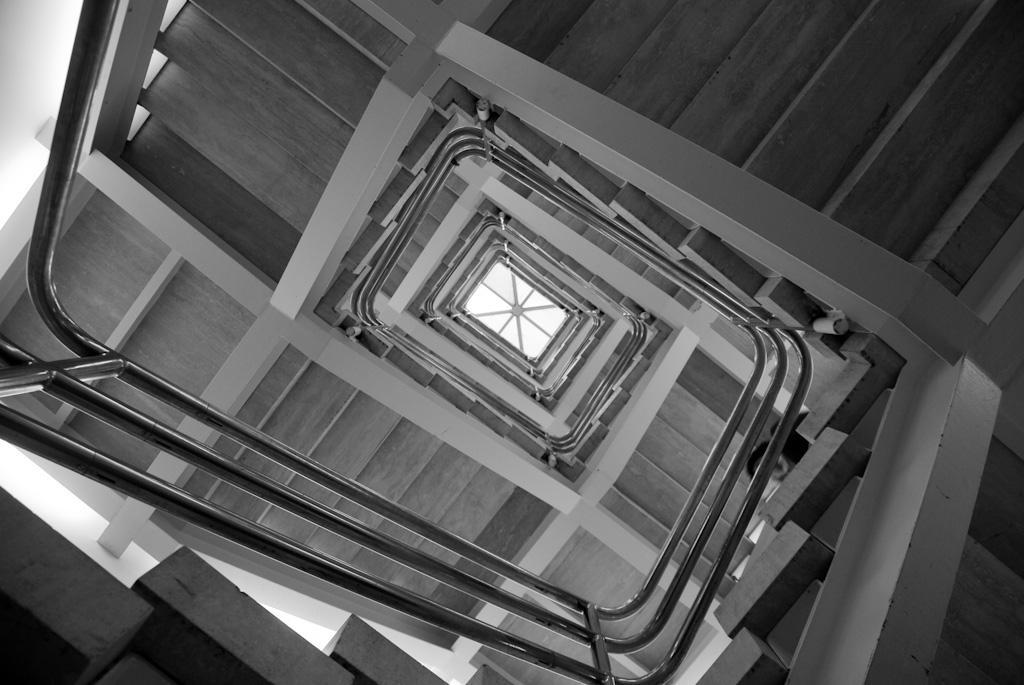What type of architectural feature can be seen in the image? There are stairs in the image. What safety feature is present alongside the stairs? There is a railing in the image. How many dogs are sitting on the table in the image? There are no dogs or tables present in the image. 